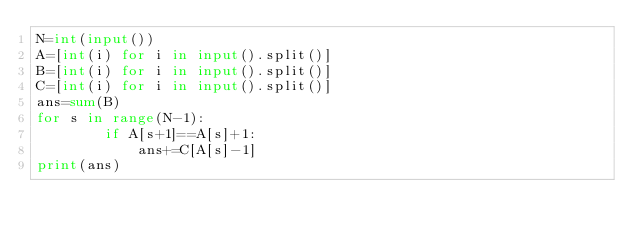<code> <loc_0><loc_0><loc_500><loc_500><_Python_>N=int(input())
A=[int(i) for i in input().split()]
B=[int(i) for i in input().split()]
C=[int(i) for i in input().split()]
ans=sum(B)
for s in range(N-1):
        if A[s+1]==A[s]+1:
            ans+=C[A[s]-1]
print(ans)
    </code> 